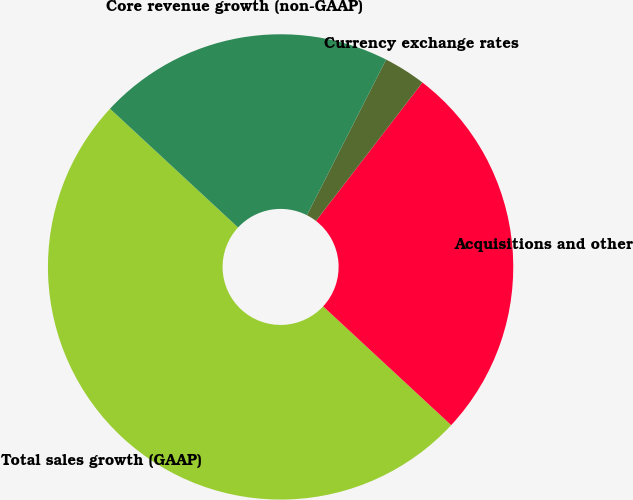Convert chart. <chart><loc_0><loc_0><loc_500><loc_500><pie_chart><fcel>Total sales growth (GAAP)<fcel>Acquisitions and other<fcel>Currency exchange rates<fcel>Core revenue growth (non-GAAP)<nl><fcel>50.0%<fcel>26.47%<fcel>2.94%<fcel>20.59%<nl></chart> 